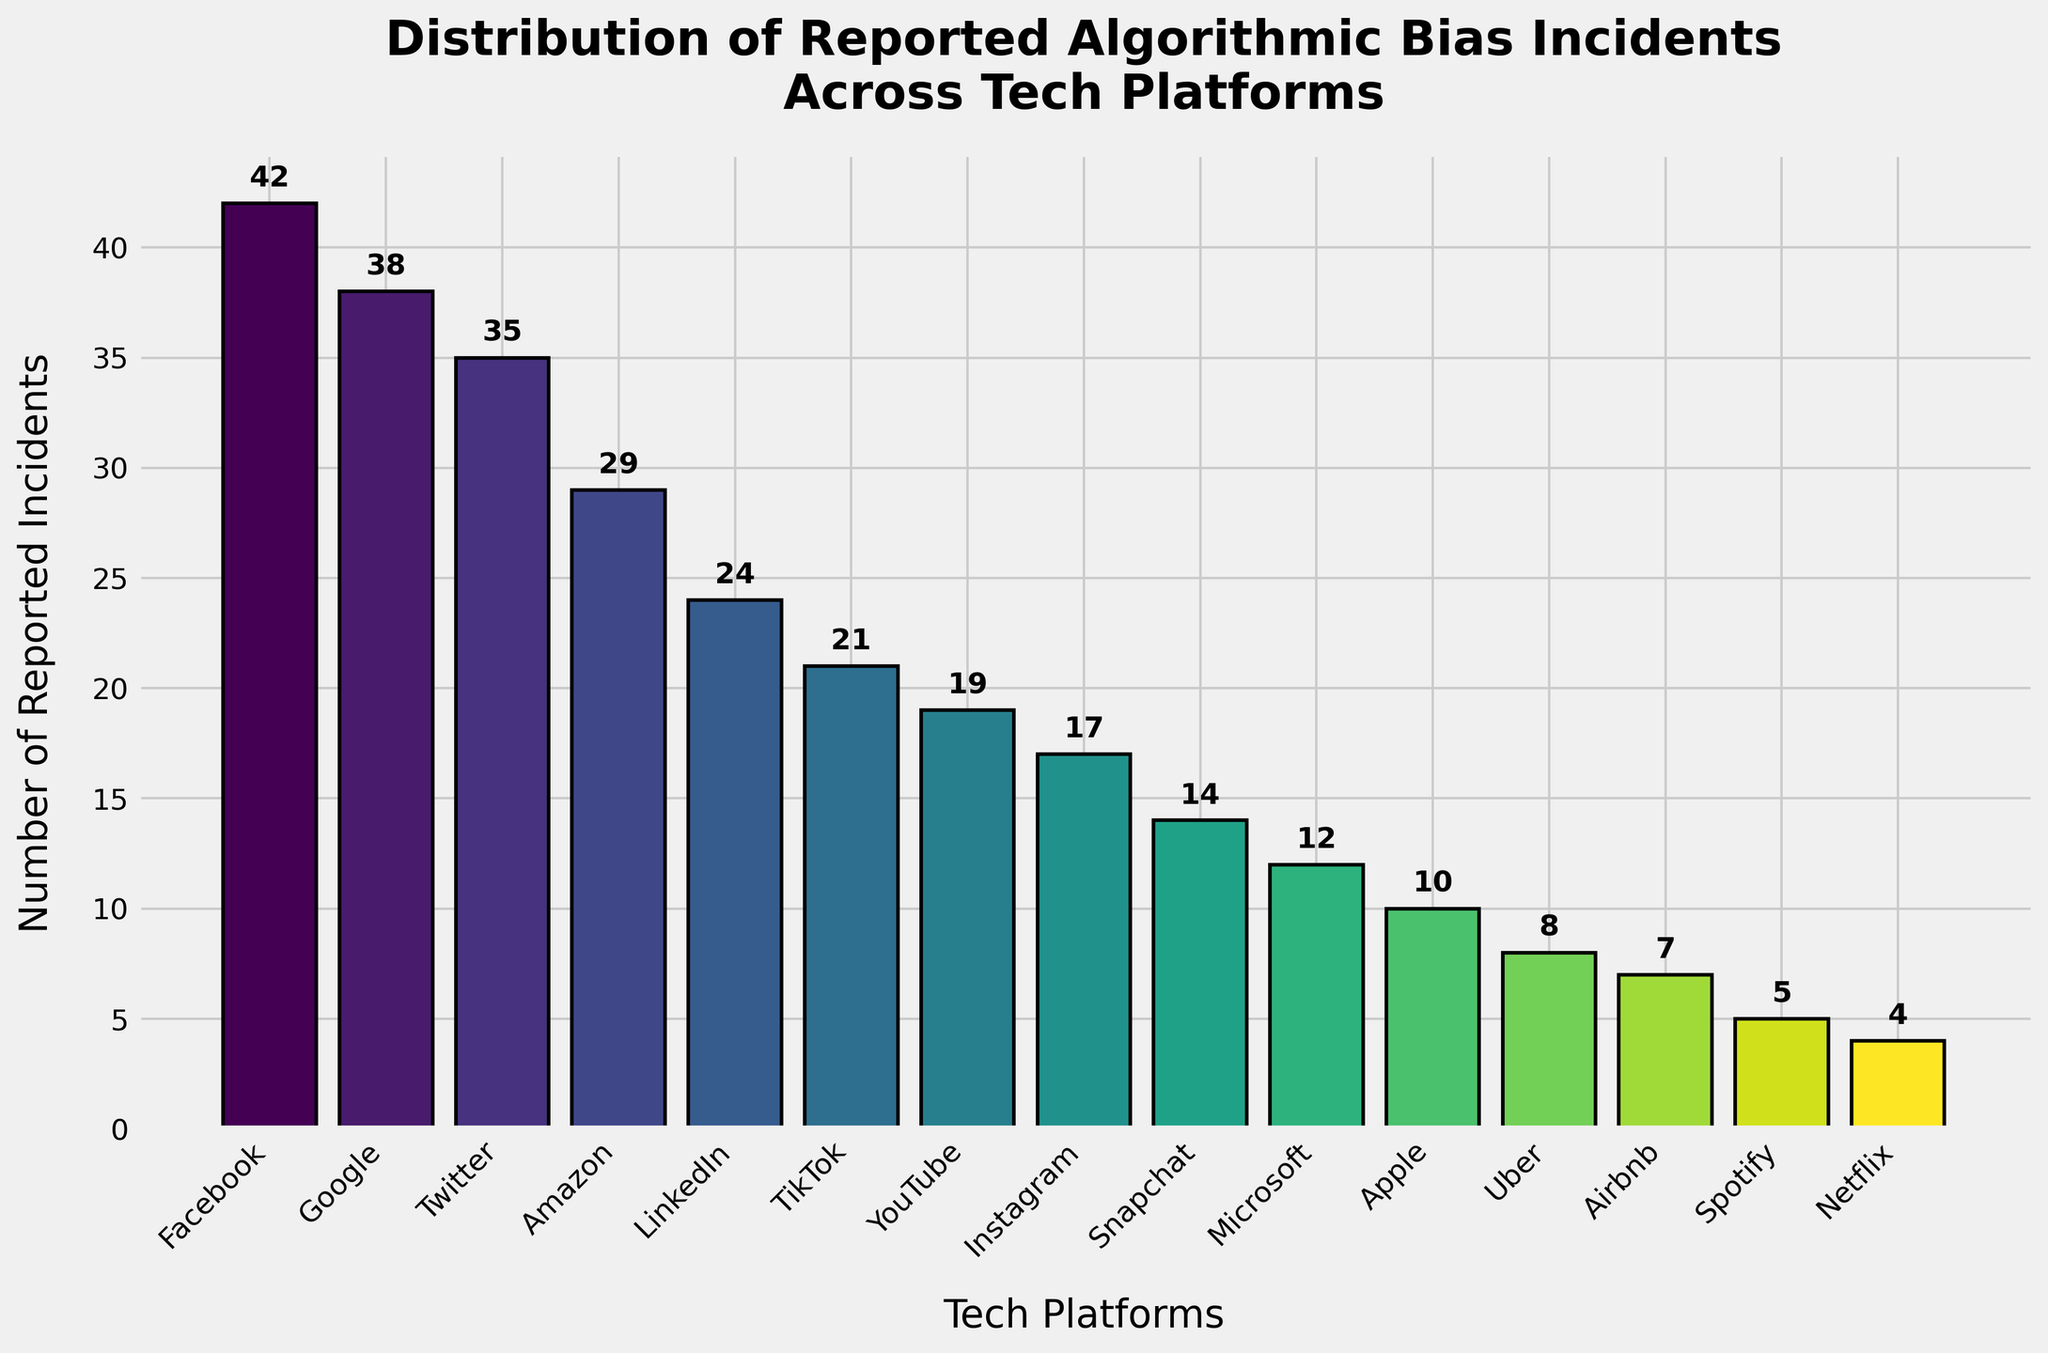What's the title of the figure? The title is at the top of the figure and usually describes the content or purpose of the chart. In this case, the title reads 'Distribution of Reported Algorithmic Bias Incidents Across Tech Platforms'.
Answer: Distribution of Reported Algorithmic Bias Incidents Across Tech Platforms Which tech platform has the highest number of reported incidents? By looking at the height of each bar, the platform with the highest bar will have the highest number of reported incidents. The bar for Facebook is the tallest.
Answer: Facebook How many reported incidents are there in total across all platforms? Sum all the values of reported incidents for each platform: 42 + 38 + 35 + 29 + 24 + 21 + 19 + 17 + 14 + 12 + 10 + 8 + 7 + 5 + 4 = 285
Answer: 285 Which platforms have fewer than 10 reported incidents? Identify the platforms where the bars have a height representing fewer than 10 incidents. Those platforms are Apple, Uber, Airbnb, Spotify, and Netflix.
Answer: Apple, Uber, Airbnb, Spotify, Netflix Compare the number of reported incidents between Twitter and YouTube. Is Twitter's count greater? Look at the height of the bars for Twitter and YouTube. Twitter has 35 incidents while YouTube has 19 incidents. Since 35 is greater than 19, Twitter's count is indeed greater.
Answer: Yes What is the range of the number of reported incidents? The range can be found by subtracting the smallest number of incidents from the largest number of incidents: 42 (Facebook) - 4 (Netflix) = 38
Answer: 38 How many platforms reported more than 20 incidents? Count the number of bars where the height is greater than 20. Those platforms are Facebook, Google, Twitter, Amazon, and LinkedIn. So, there are 5 platforms.
Answer: 5 If you average the reported incidents of TikTok, Instagram, and Snapchat, what do you get? Add the number of incidents for TikTok, Instagram, and Snapchat, then divide by 3: (21 + 17 + 14) / 3 = 52 / 3 ≈ 17.33
Answer: ~17.33 Between Amazon and LinkedIn, which platform has fewer reported incidents and by how many? Compare the height of the bars for Amazon and LinkedIn. Amazon has 29 incidents and LinkedIn has 24 incidents. The difference is 29 - 24 = 5, so LinkedIn has fewer incidents by 5.
Answer: LinkedIn by 5 